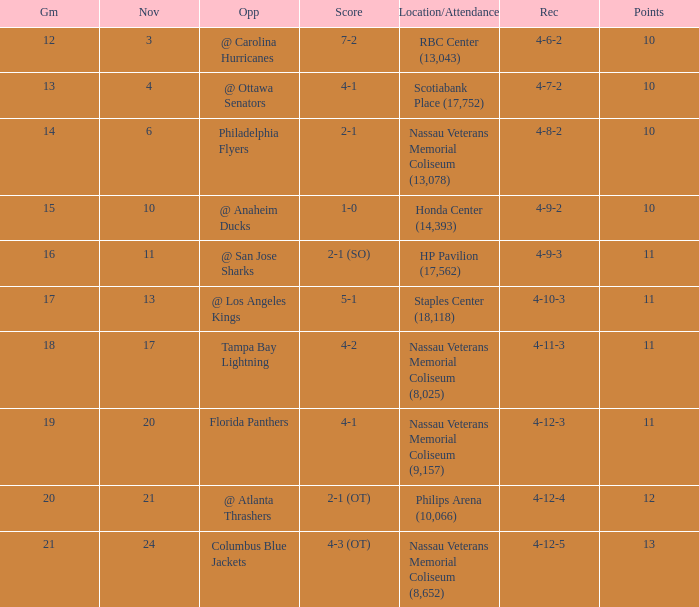What is every game on November 21? 20.0. 